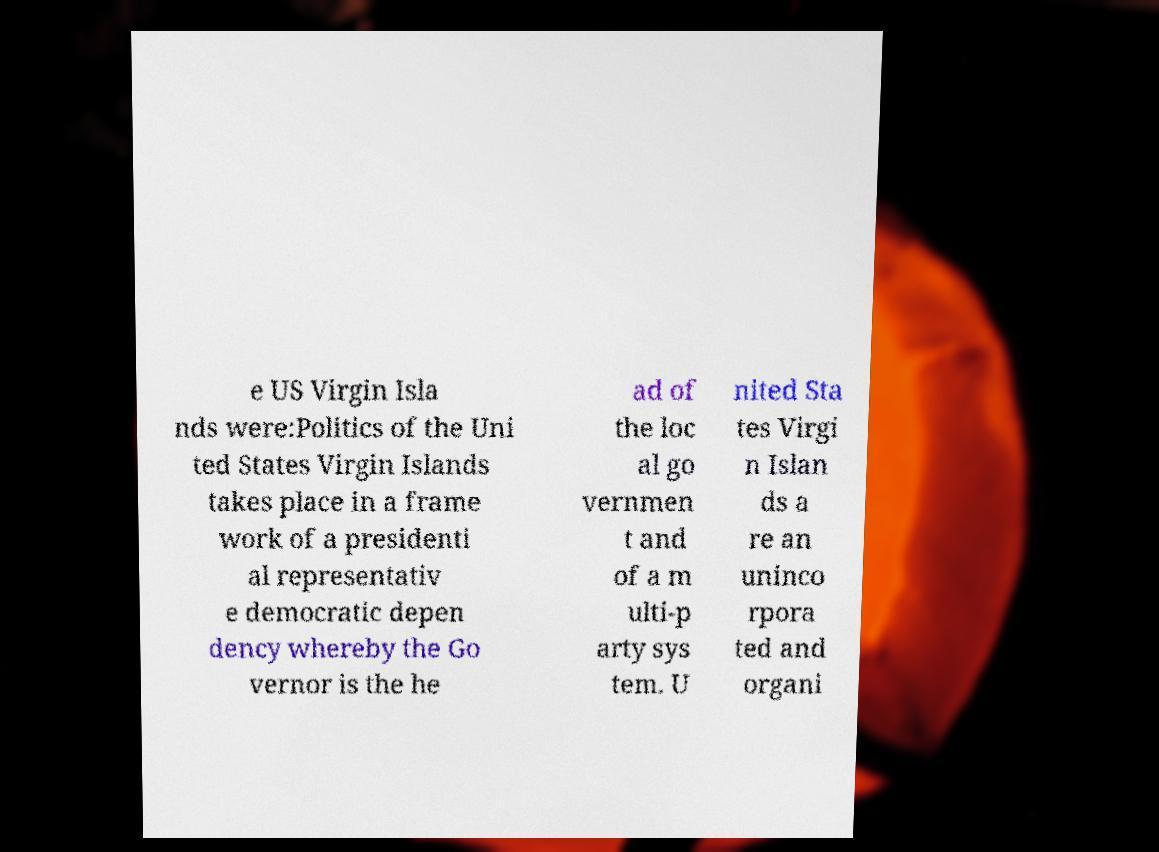Can you accurately transcribe the text from the provided image for me? e US Virgin Isla nds were:Politics of the Uni ted States Virgin Islands takes place in a frame work of a presidenti al representativ e democratic depen dency whereby the Go vernor is the he ad of the loc al go vernmen t and of a m ulti-p arty sys tem. U nited Sta tes Virgi n Islan ds a re an uninco rpora ted and organi 